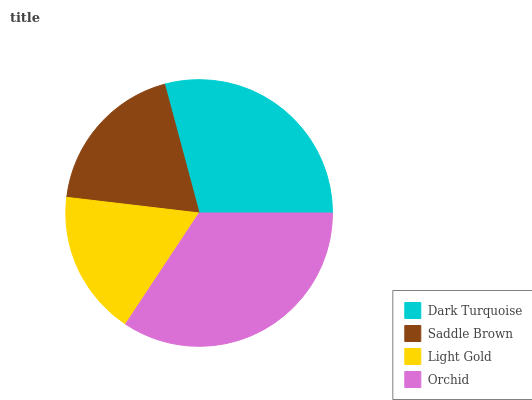Is Light Gold the minimum?
Answer yes or no. Yes. Is Orchid the maximum?
Answer yes or no. Yes. Is Saddle Brown the minimum?
Answer yes or no. No. Is Saddle Brown the maximum?
Answer yes or no. No. Is Dark Turquoise greater than Saddle Brown?
Answer yes or no. Yes. Is Saddle Brown less than Dark Turquoise?
Answer yes or no. Yes. Is Saddle Brown greater than Dark Turquoise?
Answer yes or no. No. Is Dark Turquoise less than Saddle Brown?
Answer yes or no. No. Is Dark Turquoise the high median?
Answer yes or no. Yes. Is Saddle Brown the low median?
Answer yes or no. Yes. Is Orchid the high median?
Answer yes or no. No. Is Orchid the low median?
Answer yes or no. No. 